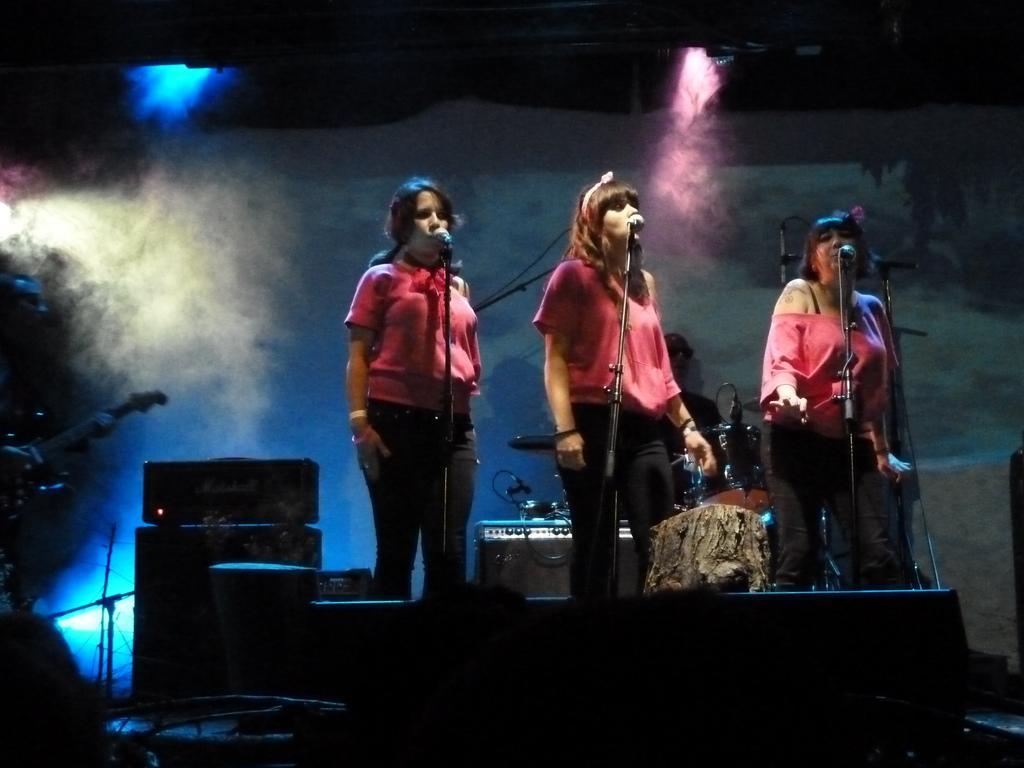Please provide a concise description of this image. In this image these women are standing on the stage. Before them there are few mike stands. Before it there is an object on the stage. Left side there is a person holding a guitar. Beside him there are few objects on the stage. Behind the women there is a musical instrument. Behind there is a person. 